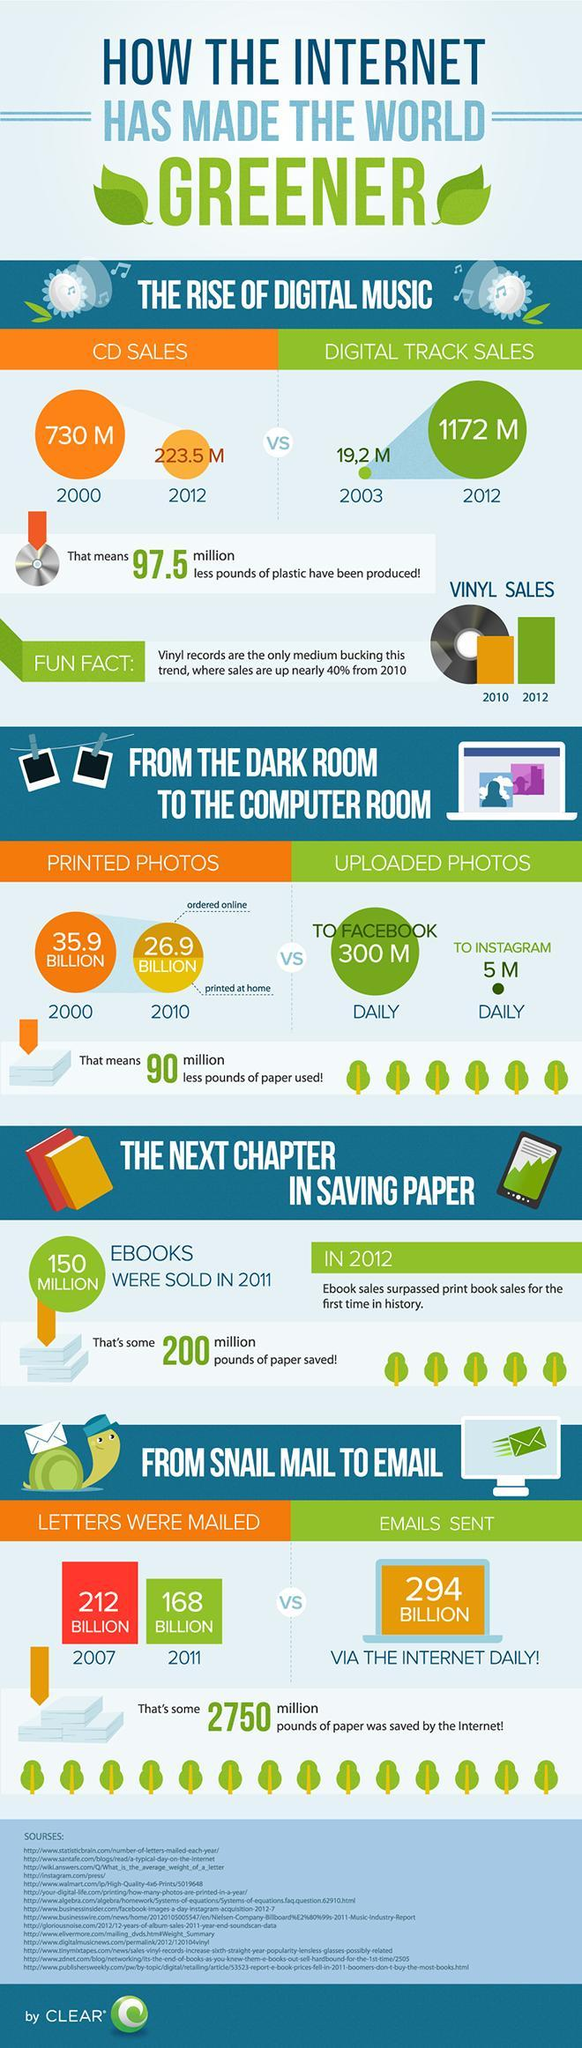which is higher in 2012 - digital track sales or cd sales?
Answer the question with a short phrase. digital track sales What is the decrease in letters (in billions) that were mailed in 2011 when compared to 2007? 44 how many million pounds of paper saved when it started to share photographs online? 90 What is the difference in number of printed photos of 2010 and 2000 in billions? 9 number of printed photos though which method is higher - online ordered or home printed? home printed daily measure of which is higher - photographs uploaded to Facebook or email sent via internet? email sent via internet which was higher in 2012 - printed book sales or e-book sales? e-book sales vinyl sales of which year is higher - 2010 or 2012? 2012 Daily uploaded photos of which platform is higher - Instagram or Facebook? facebook how many million pounds of paper saved because of e-books? 200 million pounds number of printed photos of which year is higher - 2010 or 2000? 2000 What is the difference between CD sales in 2012 and 2000 in millions? 476.5 